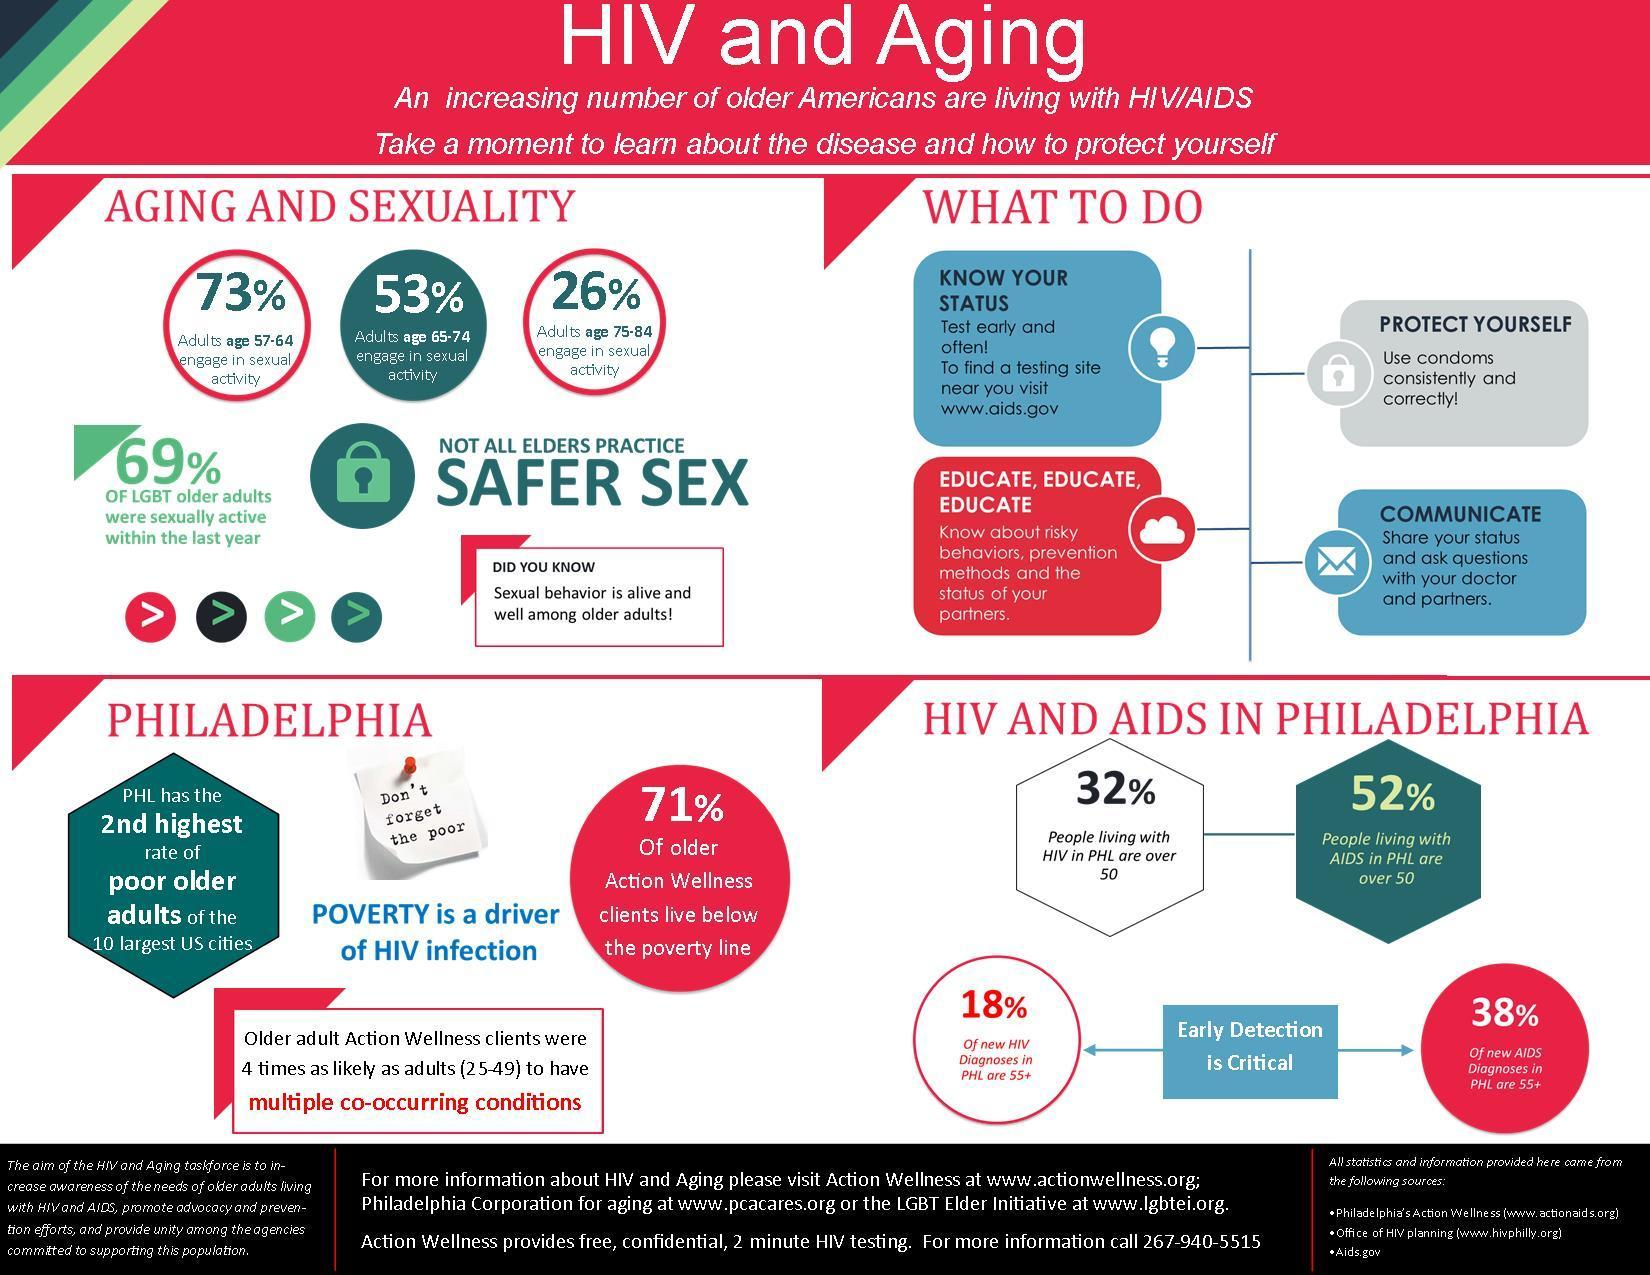What percentage of adults in the age group of 57-64 do not engage in sexual activity in America?
Answer the question with a short phrase. 27% What percentage of adults in the age group of 65-74 are engaged in sexual activity in America? 53% In which age group, 18% of new HIV cases were diagonised in Philadelphia? 55+ What percentage of LGBT older adults in America were not sexually active within the last year? 31% What percentage of people living with AIDS in Philadelphia are over 50? 52% In which age group, 38% of new AIDS cases were diagonised in Philadelphia? 55+ 